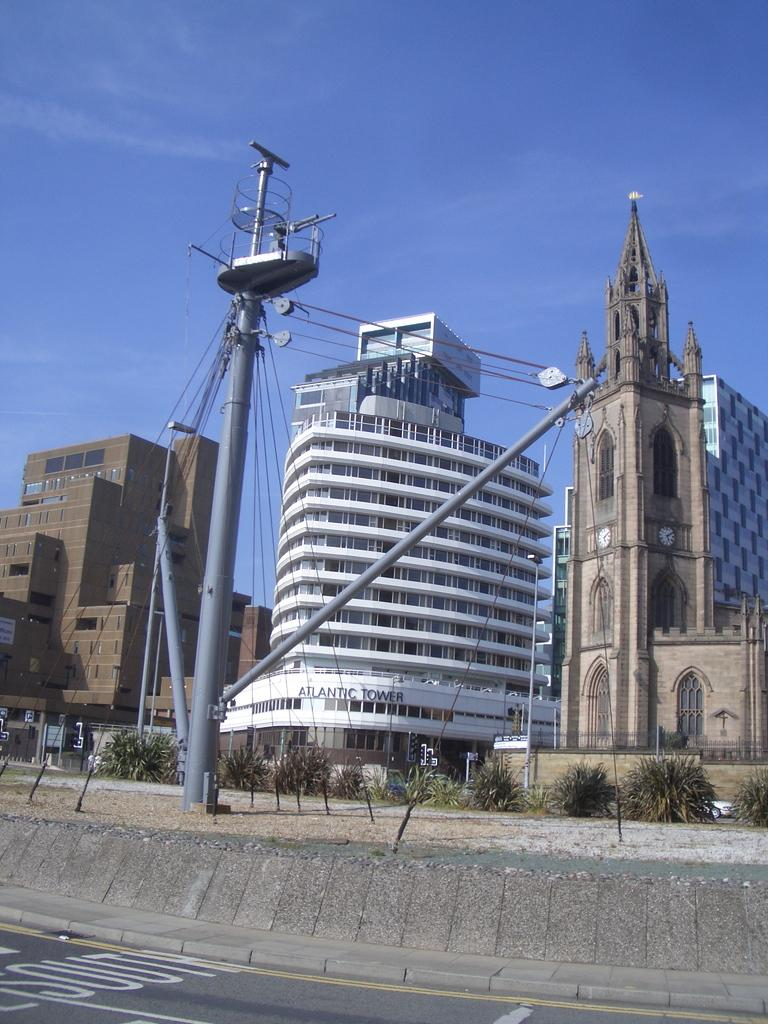What is the main feature of the image? There is a road in the image. What else can be seen along the road? There is a pole, wires, shrubs, and a tower in the image. Are there any structures visible in the image? Yes, there are buildings in the image. What is the color of the sky in the background of the image? The sky is blue in the background of the image. What type of force is being applied to the shrubs in the image? There is no force being applied to the shrubs in the image; they are stationary. What kind of bait is being used to catch fish in the image? There is no fishing or bait present in the image. 